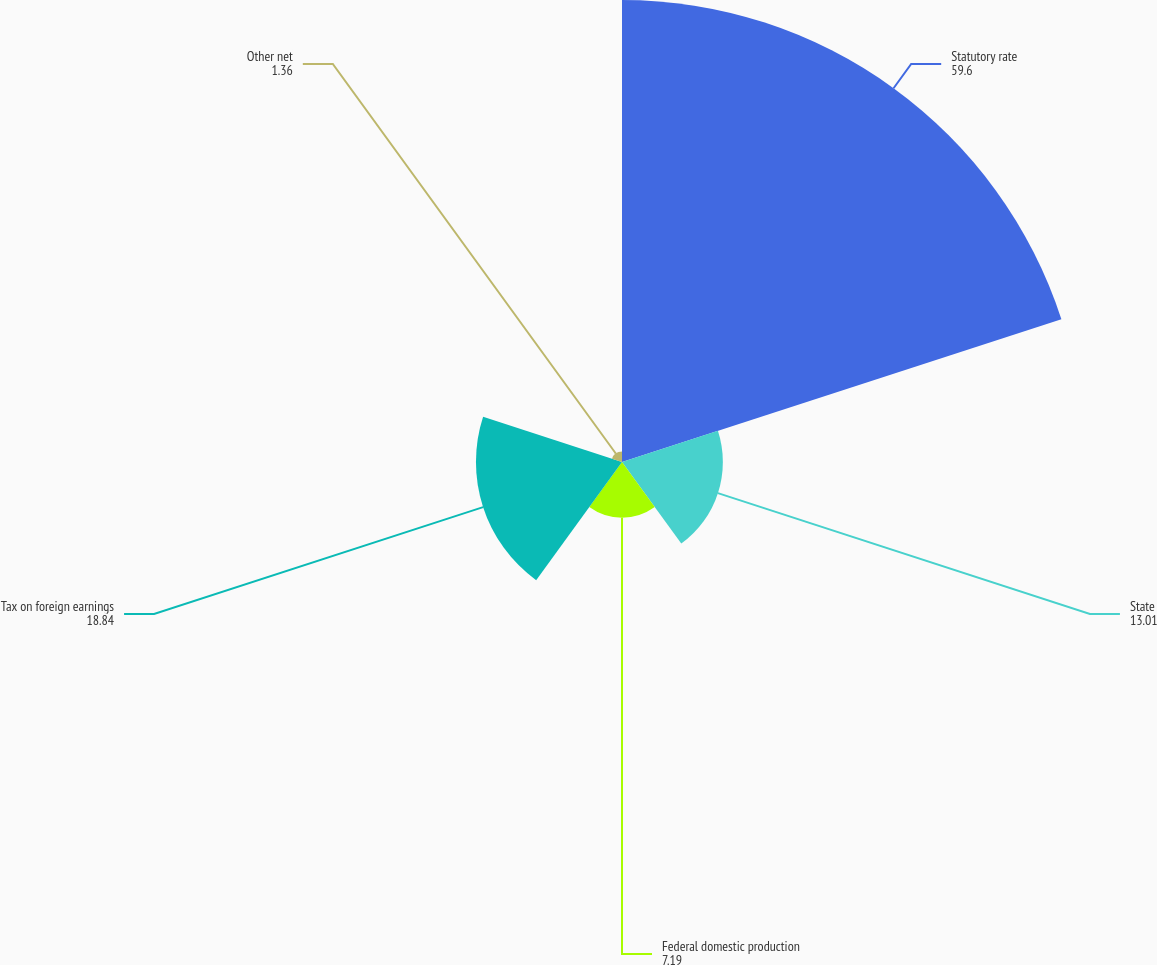Convert chart to OTSL. <chart><loc_0><loc_0><loc_500><loc_500><pie_chart><fcel>Statutory rate<fcel>State<fcel>Federal domestic production<fcel>Tax on foreign earnings<fcel>Other net<nl><fcel>59.6%<fcel>13.01%<fcel>7.19%<fcel>18.84%<fcel>1.36%<nl></chart> 